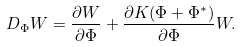<formula> <loc_0><loc_0><loc_500><loc_500>D _ { \Phi } W = \frac { \partial W } { \partial \Phi } + \frac { \partial K ( \Phi + \Phi ^ { \ast } ) } { \partial \Phi } W .</formula> 